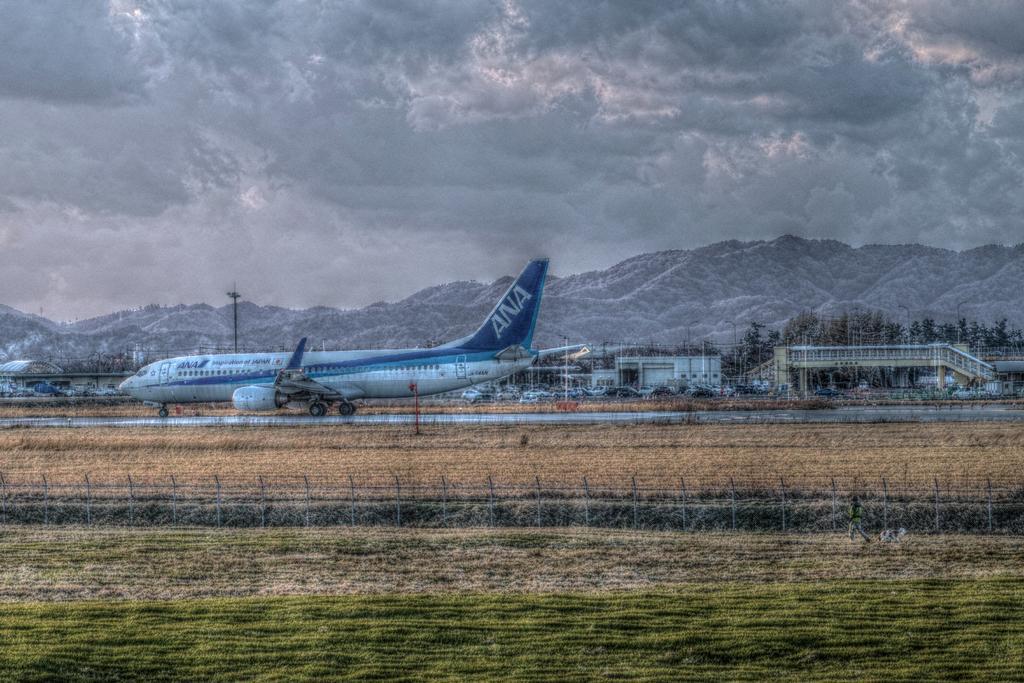Describe this image in one or two sentences. In this image we can see an airplane on the runway and there is a fence and grass on the ground and there is a person walking on the right side of the image. We can see some vehicles and buildings and there are some trees and in the background, we can see the mountains and at the top we can see the sky with clouds. 